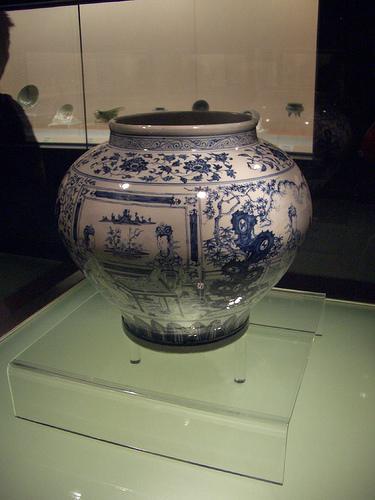Is this a Chinese vase?
Be succinct. Yes. Could this be a museum?
Give a very brief answer. Yes. What is the lady called on the vase?
Answer briefly. Geisha. Why is this vase being protected?
Give a very brief answer. Valuable. 